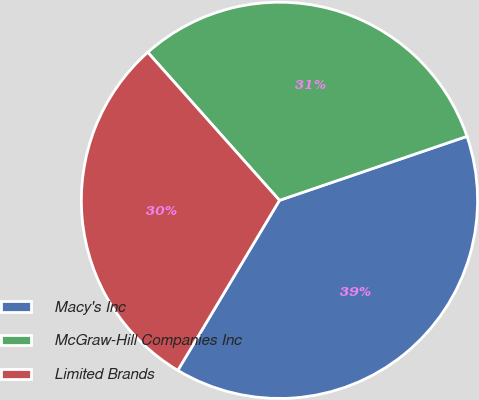<chart> <loc_0><loc_0><loc_500><loc_500><pie_chart><fcel>Macy's Inc<fcel>McGraw-Hill Companies Inc<fcel>Limited Brands<nl><fcel>38.81%<fcel>31.34%<fcel>29.85%<nl></chart> 